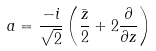<formula> <loc_0><loc_0><loc_500><loc_500>a = \frac { - i } { \sqrt { 2 } } \left ( \frac { \bar { z } } { 2 } + 2 \frac { \partial } { \partial z } \right )</formula> 